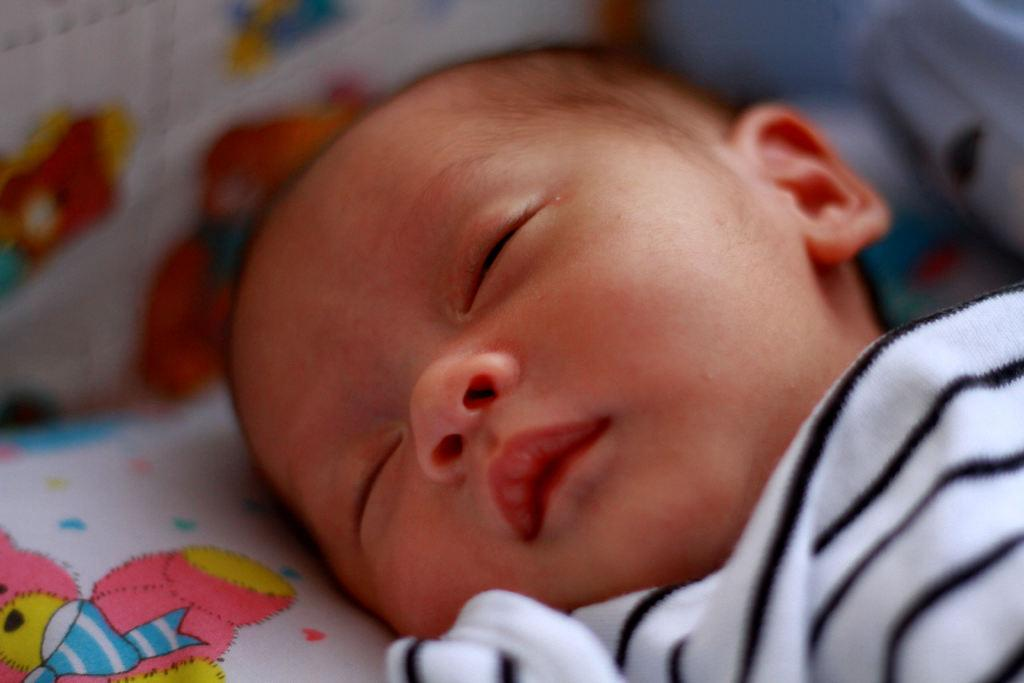What is the main subject of the image? The main subject of the image is a kid. What is the kid doing in the image? The kid is sleeping. What type of jail can be seen in the background of the image? There is no jail present in the image; it only features a kid who is sleeping. How many pies is the kid holding in the image? The kid is not holding any pies in the image; they are sleeping. 